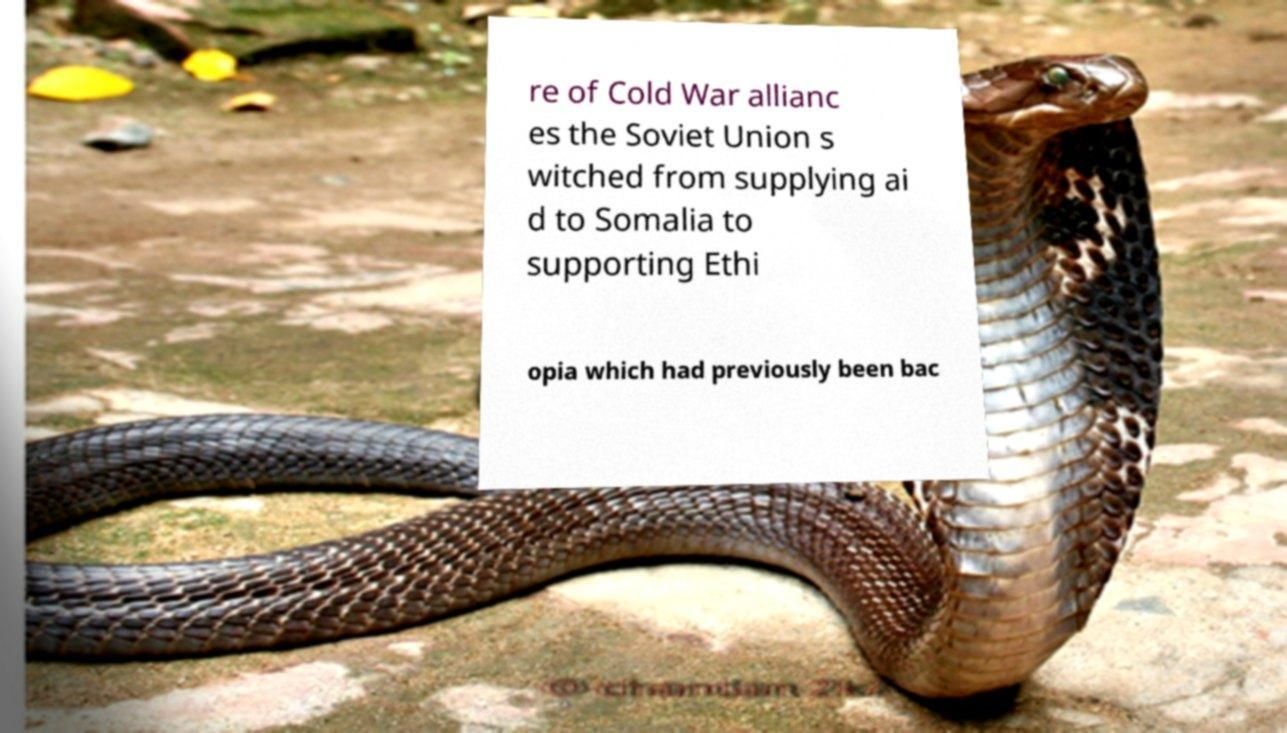Could you extract and type out the text from this image? re of Cold War allianc es the Soviet Union s witched from supplying ai d to Somalia to supporting Ethi opia which had previously been bac 